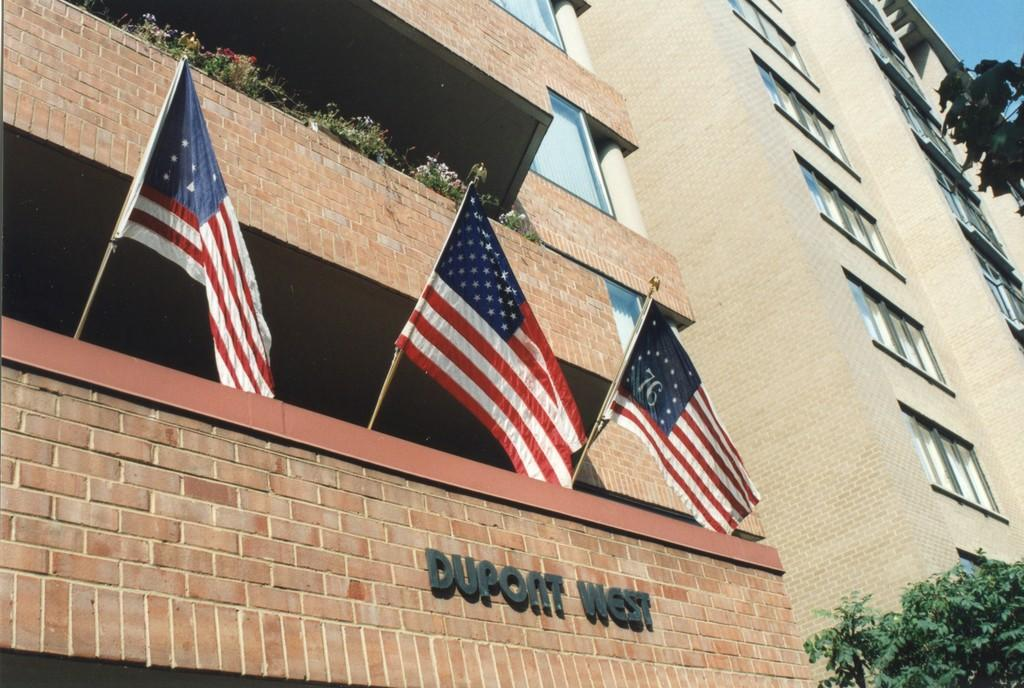What can be seen flying in the image? There are flags in the image. What type of structures are present in the image? There are buildings in the image. What type of natural elements can be seen in the image? There are trees and plants in the image. Can you read any text in the image? There is a name on a building in the image. What part of the sky is visible in the image? The sky is visible on the right side of the image. What type of basketball game is being played in the image? There is no basketball game present in the image. Can you describe the level of detail in the image? The level of detail cannot be determined from the provided facts, as they do not mention any specific details or features. 